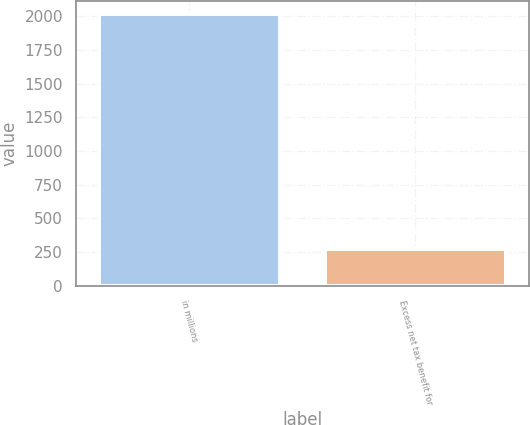Convert chart to OTSL. <chart><loc_0><loc_0><loc_500><loc_500><bar_chart><fcel>in millions<fcel>Excess net tax benefit for<nl><fcel>2016<fcel>272.7<nl></chart> 